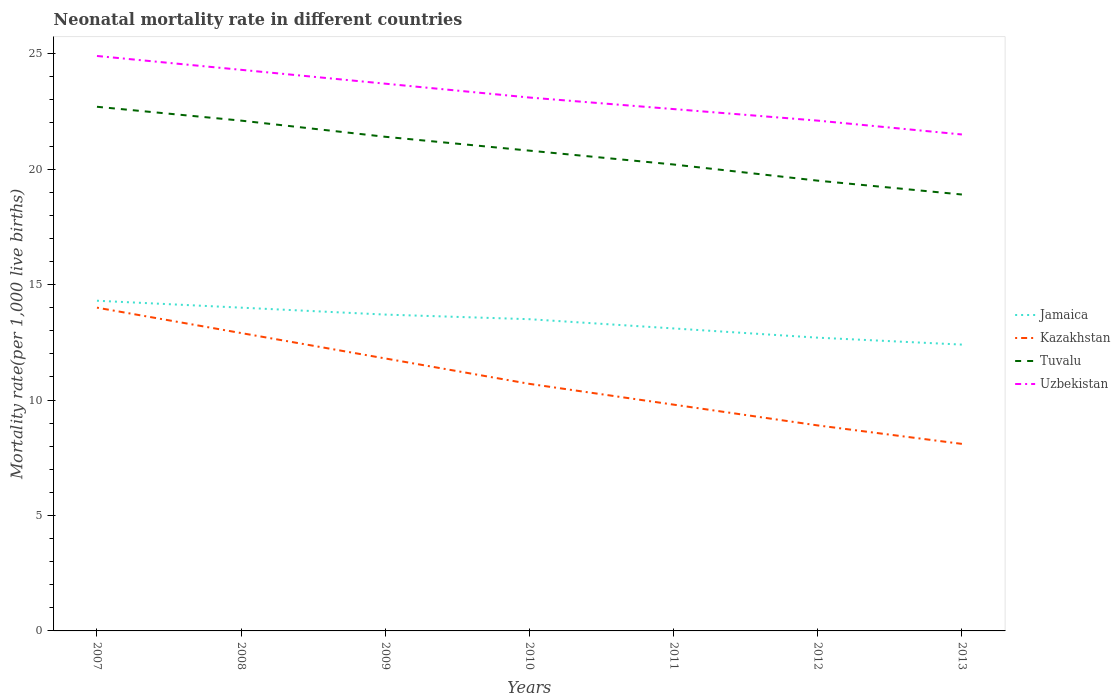Does the line corresponding to Jamaica intersect with the line corresponding to Kazakhstan?
Give a very brief answer. No. What is the total neonatal mortality rate in Tuvalu in the graph?
Provide a succinct answer. 1.9. What is the difference between the highest and the second highest neonatal mortality rate in Jamaica?
Ensure brevity in your answer.  1.9. Is the neonatal mortality rate in Jamaica strictly greater than the neonatal mortality rate in Tuvalu over the years?
Offer a terse response. Yes. How many lines are there?
Your answer should be compact. 4. How many years are there in the graph?
Keep it short and to the point. 7. Does the graph contain any zero values?
Your answer should be very brief. No. Does the graph contain grids?
Ensure brevity in your answer.  No. Where does the legend appear in the graph?
Your response must be concise. Center right. How are the legend labels stacked?
Your response must be concise. Vertical. What is the title of the graph?
Provide a short and direct response. Neonatal mortality rate in different countries. Does "Ukraine" appear as one of the legend labels in the graph?
Keep it short and to the point. No. What is the label or title of the Y-axis?
Your answer should be very brief. Mortality rate(per 1,0 live births). What is the Mortality rate(per 1,000 live births) in Jamaica in 2007?
Provide a succinct answer. 14.3. What is the Mortality rate(per 1,000 live births) of Kazakhstan in 2007?
Make the answer very short. 14. What is the Mortality rate(per 1,000 live births) of Tuvalu in 2007?
Make the answer very short. 22.7. What is the Mortality rate(per 1,000 live births) of Uzbekistan in 2007?
Your response must be concise. 24.9. What is the Mortality rate(per 1,000 live births) of Kazakhstan in 2008?
Keep it short and to the point. 12.9. What is the Mortality rate(per 1,000 live births) of Tuvalu in 2008?
Your answer should be compact. 22.1. What is the Mortality rate(per 1,000 live births) in Uzbekistan in 2008?
Provide a succinct answer. 24.3. What is the Mortality rate(per 1,000 live births) of Jamaica in 2009?
Provide a short and direct response. 13.7. What is the Mortality rate(per 1,000 live births) of Kazakhstan in 2009?
Give a very brief answer. 11.8. What is the Mortality rate(per 1,000 live births) of Tuvalu in 2009?
Offer a very short reply. 21.4. What is the Mortality rate(per 1,000 live births) of Uzbekistan in 2009?
Your answer should be compact. 23.7. What is the Mortality rate(per 1,000 live births) of Tuvalu in 2010?
Keep it short and to the point. 20.8. What is the Mortality rate(per 1,000 live births) of Uzbekistan in 2010?
Give a very brief answer. 23.1. What is the Mortality rate(per 1,000 live births) in Tuvalu in 2011?
Offer a terse response. 20.2. What is the Mortality rate(per 1,000 live births) in Uzbekistan in 2011?
Make the answer very short. 22.6. What is the Mortality rate(per 1,000 live births) of Jamaica in 2012?
Ensure brevity in your answer.  12.7. What is the Mortality rate(per 1,000 live births) in Tuvalu in 2012?
Your answer should be compact. 19.5. What is the Mortality rate(per 1,000 live births) in Uzbekistan in 2012?
Provide a short and direct response. 22.1. What is the Mortality rate(per 1,000 live births) of Jamaica in 2013?
Make the answer very short. 12.4. What is the Mortality rate(per 1,000 live births) in Kazakhstan in 2013?
Offer a very short reply. 8.1. What is the Mortality rate(per 1,000 live births) in Tuvalu in 2013?
Ensure brevity in your answer.  18.9. Across all years, what is the maximum Mortality rate(per 1,000 live births) in Tuvalu?
Give a very brief answer. 22.7. Across all years, what is the maximum Mortality rate(per 1,000 live births) in Uzbekistan?
Give a very brief answer. 24.9. Across all years, what is the minimum Mortality rate(per 1,000 live births) of Jamaica?
Make the answer very short. 12.4. Across all years, what is the minimum Mortality rate(per 1,000 live births) of Tuvalu?
Provide a short and direct response. 18.9. Across all years, what is the minimum Mortality rate(per 1,000 live births) in Uzbekistan?
Your answer should be compact. 21.5. What is the total Mortality rate(per 1,000 live births) of Jamaica in the graph?
Provide a short and direct response. 93.7. What is the total Mortality rate(per 1,000 live births) in Kazakhstan in the graph?
Make the answer very short. 76.2. What is the total Mortality rate(per 1,000 live births) of Tuvalu in the graph?
Keep it short and to the point. 145.6. What is the total Mortality rate(per 1,000 live births) in Uzbekistan in the graph?
Give a very brief answer. 162.2. What is the difference between the Mortality rate(per 1,000 live births) of Kazakhstan in 2007 and that in 2008?
Your answer should be compact. 1.1. What is the difference between the Mortality rate(per 1,000 live births) of Kazakhstan in 2007 and that in 2009?
Provide a succinct answer. 2.2. What is the difference between the Mortality rate(per 1,000 live births) of Tuvalu in 2007 and that in 2009?
Your answer should be compact. 1.3. What is the difference between the Mortality rate(per 1,000 live births) in Uzbekistan in 2007 and that in 2009?
Keep it short and to the point. 1.2. What is the difference between the Mortality rate(per 1,000 live births) of Uzbekistan in 2007 and that in 2010?
Provide a succinct answer. 1.8. What is the difference between the Mortality rate(per 1,000 live births) of Uzbekistan in 2007 and that in 2011?
Provide a succinct answer. 2.3. What is the difference between the Mortality rate(per 1,000 live births) in Tuvalu in 2007 and that in 2012?
Make the answer very short. 3.2. What is the difference between the Mortality rate(per 1,000 live births) of Jamaica in 2007 and that in 2013?
Ensure brevity in your answer.  1.9. What is the difference between the Mortality rate(per 1,000 live births) of Kazakhstan in 2007 and that in 2013?
Offer a terse response. 5.9. What is the difference between the Mortality rate(per 1,000 live births) in Tuvalu in 2007 and that in 2013?
Make the answer very short. 3.8. What is the difference between the Mortality rate(per 1,000 live births) in Uzbekistan in 2007 and that in 2013?
Keep it short and to the point. 3.4. What is the difference between the Mortality rate(per 1,000 live births) in Jamaica in 2008 and that in 2009?
Provide a succinct answer. 0.3. What is the difference between the Mortality rate(per 1,000 live births) in Uzbekistan in 2008 and that in 2009?
Your answer should be very brief. 0.6. What is the difference between the Mortality rate(per 1,000 live births) in Jamaica in 2008 and that in 2010?
Your response must be concise. 0.5. What is the difference between the Mortality rate(per 1,000 live births) in Tuvalu in 2008 and that in 2010?
Provide a short and direct response. 1.3. What is the difference between the Mortality rate(per 1,000 live births) in Jamaica in 2008 and that in 2011?
Your answer should be very brief. 0.9. What is the difference between the Mortality rate(per 1,000 live births) in Uzbekistan in 2008 and that in 2011?
Provide a succinct answer. 1.7. What is the difference between the Mortality rate(per 1,000 live births) of Jamaica in 2008 and that in 2013?
Ensure brevity in your answer.  1.6. What is the difference between the Mortality rate(per 1,000 live births) in Tuvalu in 2008 and that in 2013?
Your response must be concise. 3.2. What is the difference between the Mortality rate(per 1,000 live births) in Uzbekistan in 2008 and that in 2013?
Offer a very short reply. 2.8. What is the difference between the Mortality rate(per 1,000 live births) in Jamaica in 2009 and that in 2010?
Give a very brief answer. 0.2. What is the difference between the Mortality rate(per 1,000 live births) of Tuvalu in 2009 and that in 2010?
Keep it short and to the point. 0.6. What is the difference between the Mortality rate(per 1,000 live births) in Kazakhstan in 2009 and that in 2011?
Keep it short and to the point. 2. What is the difference between the Mortality rate(per 1,000 live births) of Tuvalu in 2009 and that in 2011?
Your answer should be compact. 1.2. What is the difference between the Mortality rate(per 1,000 live births) in Uzbekistan in 2009 and that in 2011?
Your answer should be very brief. 1.1. What is the difference between the Mortality rate(per 1,000 live births) of Kazakhstan in 2009 and that in 2012?
Give a very brief answer. 2.9. What is the difference between the Mortality rate(per 1,000 live births) of Uzbekistan in 2009 and that in 2012?
Keep it short and to the point. 1.6. What is the difference between the Mortality rate(per 1,000 live births) in Jamaica in 2010 and that in 2011?
Keep it short and to the point. 0.4. What is the difference between the Mortality rate(per 1,000 live births) in Tuvalu in 2010 and that in 2011?
Offer a very short reply. 0.6. What is the difference between the Mortality rate(per 1,000 live births) in Kazakhstan in 2010 and that in 2013?
Ensure brevity in your answer.  2.6. What is the difference between the Mortality rate(per 1,000 live births) in Uzbekistan in 2010 and that in 2013?
Your response must be concise. 1.6. What is the difference between the Mortality rate(per 1,000 live births) of Kazakhstan in 2011 and that in 2012?
Give a very brief answer. 0.9. What is the difference between the Mortality rate(per 1,000 live births) in Tuvalu in 2011 and that in 2012?
Your answer should be very brief. 0.7. What is the difference between the Mortality rate(per 1,000 live births) in Kazakhstan in 2011 and that in 2013?
Your response must be concise. 1.7. What is the difference between the Mortality rate(per 1,000 live births) of Tuvalu in 2011 and that in 2013?
Your answer should be compact. 1.3. What is the difference between the Mortality rate(per 1,000 live births) of Uzbekistan in 2011 and that in 2013?
Make the answer very short. 1.1. What is the difference between the Mortality rate(per 1,000 live births) in Jamaica in 2012 and that in 2013?
Provide a succinct answer. 0.3. What is the difference between the Mortality rate(per 1,000 live births) in Kazakhstan in 2012 and that in 2013?
Offer a terse response. 0.8. What is the difference between the Mortality rate(per 1,000 live births) in Tuvalu in 2012 and that in 2013?
Give a very brief answer. 0.6. What is the difference between the Mortality rate(per 1,000 live births) of Uzbekistan in 2012 and that in 2013?
Make the answer very short. 0.6. What is the difference between the Mortality rate(per 1,000 live births) in Jamaica in 2007 and the Mortality rate(per 1,000 live births) in Kazakhstan in 2008?
Offer a terse response. 1.4. What is the difference between the Mortality rate(per 1,000 live births) of Kazakhstan in 2007 and the Mortality rate(per 1,000 live births) of Tuvalu in 2008?
Your answer should be very brief. -8.1. What is the difference between the Mortality rate(per 1,000 live births) in Kazakhstan in 2007 and the Mortality rate(per 1,000 live births) in Uzbekistan in 2008?
Your answer should be very brief. -10.3. What is the difference between the Mortality rate(per 1,000 live births) in Tuvalu in 2007 and the Mortality rate(per 1,000 live births) in Uzbekistan in 2008?
Your answer should be compact. -1.6. What is the difference between the Mortality rate(per 1,000 live births) in Jamaica in 2007 and the Mortality rate(per 1,000 live births) in Tuvalu in 2009?
Make the answer very short. -7.1. What is the difference between the Mortality rate(per 1,000 live births) in Jamaica in 2007 and the Mortality rate(per 1,000 live births) in Uzbekistan in 2009?
Keep it short and to the point. -9.4. What is the difference between the Mortality rate(per 1,000 live births) in Kazakhstan in 2007 and the Mortality rate(per 1,000 live births) in Tuvalu in 2009?
Make the answer very short. -7.4. What is the difference between the Mortality rate(per 1,000 live births) of Tuvalu in 2007 and the Mortality rate(per 1,000 live births) of Uzbekistan in 2009?
Give a very brief answer. -1. What is the difference between the Mortality rate(per 1,000 live births) of Jamaica in 2007 and the Mortality rate(per 1,000 live births) of Kazakhstan in 2010?
Give a very brief answer. 3.6. What is the difference between the Mortality rate(per 1,000 live births) of Jamaica in 2007 and the Mortality rate(per 1,000 live births) of Tuvalu in 2010?
Your answer should be very brief. -6.5. What is the difference between the Mortality rate(per 1,000 live births) of Jamaica in 2007 and the Mortality rate(per 1,000 live births) of Uzbekistan in 2010?
Make the answer very short. -8.8. What is the difference between the Mortality rate(per 1,000 live births) of Jamaica in 2007 and the Mortality rate(per 1,000 live births) of Kazakhstan in 2011?
Make the answer very short. 4.5. What is the difference between the Mortality rate(per 1,000 live births) of Jamaica in 2007 and the Mortality rate(per 1,000 live births) of Kazakhstan in 2012?
Offer a terse response. 5.4. What is the difference between the Mortality rate(per 1,000 live births) of Jamaica in 2007 and the Mortality rate(per 1,000 live births) of Tuvalu in 2012?
Make the answer very short. -5.2. What is the difference between the Mortality rate(per 1,000 live births) in Jamaica in 2007 and the Mortality rate(per 1,000 live births) in Uzbekistan in 2012?
Your answer should be compact. -7.8. What is the difference between the Mortality rate(per 1,000 live births) of Jamaica in 2007 and the Mortality rate(per 1,000 live births) of Uzbekistan in 2013?
Offer a very short reply. -7.2. What is the difference between the Mortality rate(per 1,000 live births) in Tuvalu in 2007 and the Mortality rate(per 1,000 live births) in Uzbekistan in 2013?
Provide a short and direct response. 1.2. What is the difference between the Mortality rate(per 1,000 live births) of Jamaica in 2008 and the Mortality rate(per 1,000 live births) of Tuvalu in 2009?
Offer a very short reply. -7.4. What is the difference between the Mortality rate(per 1,000 live births) of Kazakhstan in 2008 and the Mortality rate(per 1,000 live births) of Tuvalu in 2009?
Offer a terse response. -8.5. What is the difference between the Mortality rate(per 1,000 live births) of Tuvalu in 2008 and the Mortality rate(per 1,000 live births) of Uzbekistan in 2009?
Ensure brevity in your answer.  -1.6. What is the difference between the Mortality rate(per 1,000 live births) in Jamaica in 2008 and the Mortality rate(per 1,000 live births) in Kazakhstan in 2010?
Give a very brief answer. 3.3. What is the difference between the Mortality rate(per 1,000 live births) in Jamaica in 2008 and the Mortality rate(per 1,000 live births) in Tuvalu in 2010?
Offer a terse response. -6.8. What is the difference between the Mortality rate(per 1,000 live births) of Jamaica in 2008 and the Mortality rate(per 1,000 live births) of Uzbekistan in 2010?
Provide a succinct answer. -9.1. What is the difference between the Mortality rate(per 1,000 live births) in Tuvalu in 2008 and the Mortality rate(per 1,000 live births) in Uzbekistan in 2010?
Offer a terse response. -1. What is the difference between the Mortality rate(per 1,000 live births) of Jamaica in 2008 and the Mortality rate(per 1,000 live births) of Kazakhstan in 2011?
Offer a very short reply. 4.2. What is the difference between the Mortality rate(per 1,000 live births) in Jamaica in 2008 and the Mortality rate(per 1,000 live births) in Uzbekistan in 2011?
Your answer should be compact. -8.6. What is the difference between the Mortality rate(per 1,000 live births) in Kazakhstan in 2008 and the Mortality rate(per 1,000 live births) in Tuvalu in 2011?
Give a very brief answer. -7.3. What is the difference between the Mortality rate(per 1,000 live births) of Jamaica in 2008 and the Mortality rate(per 1,000 live births) of Kazakhstan in 2012?
Keep it short and to the point. 5.1. What is the difference between the Mortality rate(per 1,000 live births) in Jamaica in 2008 and the Mortality rate(per 1,000 live births) in Tuvalu in 2012?
Your answer should be very brief. -5.5. What is the difference between the Mortality rate(per 1,000 live births) of Jamaica in 2008 and the Mortality rate(per 1,000 live births) of Uzbekistan in 2012?
Make the answer very short. -8.1. What is the difference between the Mortality rate(per 1,000 live births) in Kazakhstan in 2008 and the Mortality rate(per 1,000 live births) in Uzbekistan in 2012?
Keep it short and to the point. -9.2. What is the difference between the Mortality rate(per 1,000 live births) in Jamaica in 2008 and the Mortality rate(per 1,000 live births) in Kazakhstan in 2013?
Make the answer very short. 5.9. What is the difference between the Mortality rate(per 1,000 live births) of Jamaica in 2008 and the Mortality rate(per 1,000 live births) of Tuvalu in 2013?
Provide a short and direct response. -4.9. What is the difference between the Mortality rate(per 1,000 live births) in Jamaica in 2008 and the Mortality rate(per 1,000 live births) in Uzbekistan in 2013?
Ensure brevity in your answer.  -7.5. What is the difference between the Mortality rate(per 1,000 live births) in Kazakhstan in 2008 and the Mortality rate(per 1,000 live births) in Tuvalu in 2013?
Make the answer very short. -6. What is the difference between the Mortality rate(per 1,000 live births) in Kazakhstan in 2008 and the Mortality rate(per 1,000 live births) in Uzbekistan in 2013?
Offer a very short reply. -8.6. What is the difference between the Mortality rate(per 1,000 live births) of Tuvalu in 2008 and the Mortality rate(per 1,000 live births) of Uzbekistan in 2013?
Keep it short and to the point. 0.6. What is the difference between the Mortality rate(per 1,000 live births) in Jamaica in 2009 and the Mortality rate(per 1,000 live births) in Uzbekistan in 2010?
Provide a short and direct response. -9.4. What is the difference between the Mortality rate(per 1,000 live births) in Kazakhstan in 2009 and the Mortality rate(per 1,000 live births) in Tuvalu in 2010?
Keep it short and to the point. -9. What is the difference between the Mortality rate(per 1,000 live births) of Kazakhstan in 2009 and the Mortality rate(per 1,000 live births) of Uzbekistan in 2010?
Offer a very short reply. -11.3. What is the difference between the Mortality rate(per 1,000 live births) in Tuvalu in 2009 and the Mortality rate(per 1,000 live births) in Uzbekistan in 2010?
Provide a succinct answer. -1.7. What is the difference between the Mortality rate(per 1,000 live births) of Jamaica in 2009 and the Mortality rate(per 1,000 live births) of Tuvalu in 2011?
Your answer should be compact. -6.5. What is the difference between the Mortality rate(per 1,000 live births) of Jamaica in 2009 and the Mortality rate(per 1,000 live births) of Uzbekistan in 2011?
Provide a succinct answer. -8.9. What is the difference between the Mortality rate(per 1,000 live births) in Kazakhstan in 2009 and the Mortality rate(per 1,000 live births) in Tuvalu in 2011?
Keep it short and to the point. -8.4. What is the difference between the Mortality rate(per 1,000 live births) of Tuvalu in 2009 and the Mortality rate(per 1,000 live births) of Uzbekistan in 2011?
Keep it short and to the point. -1.2. What is the difference between the Mortality rate(per 1,000 live births) in Jamaica in 2009 and the Mortality rate(per 1,000 live births) in Uzbekistan in 2012?
Offer a very short reply. -8.4. What is the difference between the Mortality rate(per 1,000 live births) in Kazakhstan in 2009 and the Mortality rate(per 1,000 live births) in Uzbekistan in 2012?
Give a very brief answer. -10.3. What is the difference between the Mortality rate(per 1,000 live births) of Jamaica in 2009 and the Mortality rate(per 1,000 live births) of Tuvalu in 2013?
Offer a terse response. -5.2. What is the difference between the Mortality rate(per 1,000 live births) in Kazakhstan in 2009 and the Mortality rate(per 1,000 live births) in Uzbekistan in 2013?
Your response must be concise. -9.7. What is the difference between the Mortality rate(per 1,000 live births) in Tuvalu in 2009 and the Mortality rate(per 1,000 live births) in Uzbekistan in 2013?
Your answer should be compact. -0.1. What is the difference between the Mortality rate(per 1,000 live births) in Jamaica in 2010 and the Mortality rate(per 1,000 live births) in Kazakhstan in 2011?
Your answer should be compact. 3.7. What is the difference between the Mortality rate(per 1,000 live births) of Jamaica in 2010 and the Mortality rate(per 1,000 live births) of Tuvalu in 2011?
Keep it short and to the point. -6.7. What is the difference between the Mortality rate(per 1,000 live births) in Jamaica in 2010 and the Mortality rate(per 1,000 live births) in Uzbekistan in 2011?
Offer a very short reply. -9.1. What is the difference between the Mortality rate(per 1,000 live births) of Tuvalu in 2010 and the Mortality rate(per 1,000 live births) of Uzbekistan in 2011?
Keep it short and to the point. -1.8. What is the difference between the Mortality rate(per 1,000 live births) of Jamaica in 2010 and the Mortality rate(per 1,000 live births) of Kazakhstan in 2012?
Offer a terse response. 4.6. What is the difference between the Mortality rate(per 1,000 live births) in Jamaica in 2010 and the Mortality rate(per 1,000 live births) in Tuvalu in 2012?
Offer a terse response. -6. What is the difference between the Mortality rate(per 1,000 live births) in Jamaica in 2010 and the Mortality rate(per 1,000 live births) in Uzbekistan in 2012?
Give a very brief answer. -8.6. What is the difference between the Mortality rate(per 1,000 live births) in Kazakhstan in 2010 and the Mortality rate(per 1,000 live births) in Uzbekistan in 2012?
Offer a very short reply. -11.4. What is the difference between the Mortality rate(per 1,000 live births) in Tuvalu in 2010 and the Mortality rate(per 1,000 live births) in Uzbekistan in 2012?
Your answer should be compact. -1.3. What is the difference between the Mortality rate(per 1,000 live births) in Jamaica in 2010 and the Mortality rate(per 1,000 live births) in Uzbekistan in 2013?
Make the answer very short. -8. What is the difference between the Mortality rate(per 1,000 live births) in Kazakhstan in 2010 and the Mortality rate(per 1,000 live births) in Uzbekistan in 2013?
Offer a very short reply. -10.8. What is the difference between the Mortality rate(per 1,000 live births) of Jamaica in 2011 and the Mortality rate(per 1,000 live births) of Tuvalu in 2012?
Your answer should be very brief. -6.4. What is the difference between the Mortality rate(per 1,000 live births) in Jamaica in 2011 and the Mortality rate(per 1,000 live births) in Uzbekistan in 2012?
Make the answer very short. -9. What is the difference between the Mortality rate(per 1,000 live births) of Kazakhstan in 2011 and the Mortality rate(per 1,000 live births) of Uzbekistan in 2012?
Make the answer very short. -12.3. What is the difference between the Mortality rate(per 1,000 live births) in Jamaica in 2011 and the Mortality rate(per 1,000 live births) in Kazakhstan in 2013?
Offer a very short reply. 5. What is the difference between the Mortality rate(per 1,000 live births) in Jamaica in 2011 and the Mortality rate(per 1,000 live births) in Uzbekistan in 2013?
Offer a very short reply. -8.4. What is the difference between the Mortality rate(per 1,000 live births) in Kazakhstan in 2011 and the Mortality rate(per 1,000 live births) in Tuvalu in 2013?
Your response must be concise. -9.1. What is the difference between the Mortality rate(per 1,000 live births) of Jamaica in 2012 and the Mortality rate(per 1,000 live births) of Kazakhstan in 2013?
Keep it short and to the point. 4.6. What is the difference between the Mortality rate(per 1,000 live births) in Jamaica in 2012 and the Mortality rate(per 1,000 live births) in Uzbekistan in 2013?
Your response must be concise. -8.8. What is the difference between the Mortality rate(per 1,000 live births) of Tuvalu in 2012 and the Mortality rate(per 1,000 live births) of Uzbekistan in 2013?
Provide a short and direct response. -2. What is the average Mortality rate(per 1,000 live births) of Jamaica per year?
Offer a terse response. 13.39. What is the average Mortality rate(per 1,000 live births) of Kazakhstan per year?
Make the answer very short. 10.89. What is the average Mortality rate(per 1,000 live births) in Tuvalu per year?
Provide a succinct answer. 20.8. What is the average Mortality rate(per 1,000 live births) in Uzbekistan per year?
Your answer should be compact. 23.17. In the year 2007, what is the difference between the Mortality rate(per 1,000 live births) of Jamaica and Mortality rate(per 1,000 live births) of Tuvalu?
Give a very brief answer. -8.4. In the year 2007, what is the difference between the Mortality rate(per 1,000 live births) of Kazakhstan and Mortality rate(per 1,000 live births) of Uzbekistan?
Offer a very short reply. -10.9. In the year 2008, what is the difference between the Mortality rate(per 1,000 live births) of Jamaica and Mortality rate(per 1,000 live births) of Kazakhstan?
Your answer should be very brief. 1.1. In the year 2008, what is the difference between the Mortality rate(per 1,000 live births) of Jamaica and Mortality rate(per 1,000 live births) of Tuvalu?
Keep it short and to the point. -8.1. In the year 2008, what is the difference between the Mortality rate(per 1,000 live births) of Kazakhstan and Mortality rate(per 1,000 live births) of Uzbekistan?
Your answer should be very brief. -11.4. In the year 2008, what is the difference between the Mortality rate(per 1,000 live births) of Tuvalu and Mortality rate(per 1,000 live births) of Uzbekistan?
Provide a short and direct response. -2.2. In the year 2009, what is the difference between the Mortality rate(per 1,000 live births) of Jamaica and Mortality rate(per 1,000 live births) of Kazakhstan?
Offer a very short reply. 1.9. In the year 2009, what is the difference between the Mortality rate(per 1,000 live births) of Jamaica and Mortality rate(per 1,000 live births) of Uzbekistan?
Make the answer very short. -10. In the year 2009, what is the difference between the Mortality rate(per 1,000 live births) of Kazakhstan and Mortality rate(per 1,000 live births) of Tuvalu?
Your answer should be compact. -9.6. In the year 2010, what is the difference between the Mortality rate(per 1,000 live births) in Kazakhstan and Mortality rate(per 1,000 live births) in Tuvalu?
Your answer should be compact. -10.1. In the year 2011, what is the difference between the Mortality rate(per 1,000 live births) of Jamaica and Mortality rate(per 1,000 live births) of Uzbekistan?
Make the answer very short. -9.5. In the year 2011, what is the difference between the Mortality rate(per 1,000 live births) in Kazakhstan and Mortality rate(per 1,000 live births) in Tuvalu?
Give a very brief answer. -10.4. In the year 2011, what is the difference between the Mortality rate(per 1,000 live births) of Kazakhstan and Mortality rate(per 1,000 live births) of Uzbekistan?
Your response must be concise. -12.8. In the year 2012, what is the difference between the Mortality rate(per 1,000 live births) in Tuvalu and Mortality rate(per 1,000 live births) in Uzbekistan?
Your response must be concise. -2.6. In the year 2013, what is the difference between the Mortality rate(per 1,000 live births) in Jamaica and Mortality rate(per 1,000 live births) in Tuvalu?
Provide a succinct answer. -6.5. In the year 2013, what is the difference between the Mortality rate(per 1,000 live births) of Jamaica and Mortality rate(per 1,000 live births) of Uzbekistan?
Your answer should be compact. -9.1. What is the ratio of the Mortality rate(per 1,000 live births) of Jamaica in 2007 to that in 2008?
Ensure brevity in your answer.  1.02. What is the ratio of the Mortality rate(per 1,000 live births) of Kazakhstan in 2007 to that in 2008?
Keep it short and to the point. 1.09. What is the ratio of the Mortality rate(per 1,000 live births) in Tuvalu in 2007 to that in 2008?
Your answer should be very brief. 1.03. What is the ratio of the Mortality rate(per 1,000 live births) of Uzbekistan in 2007 to that in 2008?
Make the answer very short. 1.02. What is the ratio of the Mortality rate(per 1,000 live births) of Jamaica in 2007 to that in 2009?
Give a very brief answer. 1.04. What is the ratio of the Mortality rate(per 1,000 live births) of Kazakhstan in 2007 to that in 2009?
Make the answer very short. 1.19. What is the ratio of the Mortality rate(per 1,000 live births) in Tuvalu in 2007 to that in 2009?
Your answer should be very brief. 1.06. What is the ratio of the Mortality rate(per 1,000 live births) of Uzbekistan in 2007 to that in 2009?
Make the answer very short. 1.05. What is the ratio of the Mortality rate(per 1,000 live births) of Jamaica in 2007 to that in 2010?
Provide a succinct answer. 1.06. What is the ratio of the Mortality rate(per 1,000 live births) in Kazakhstan in 2007 to that in 2010?
Offer a very short reply. 1.31. What is the ratio of the Mortality rate(per 1,000 live births) in Tuvalu in 2007 to that in 2010?
Provide a succinct answer. 1.09. What is the ratio of the Mortality rate(per 1,000 live births) of Uzbekistan in 2007 to that in 2010?
Make the answer very short. 1.08. What is the ratio of the Mortality rate(per 1,000 live births) in Jamaica in 2007 to that in 2011?
Keep it short and to the point. 1.09. What is the ratio of the Mortality rate(per 1,000 live births) of Kazakhstan in 2007 to that in 2011?
Your answer should be compact. 1.43. What is the ratio of the Mortality rate(per 1,000 live births) of Tuvalu in 2007 to that in 2011?
Give a very brief answer. 1.12. What is the ratio of the Mortality rate(per 1,000 live births) of Uzbekistan in 2007 to that in 2011?
Make the answer very short. 1.1. What is the ratio of the Mortality rate(per 1,000 live births) of Jamaica in 2007 to that in 2012?
Your answer should be very brief. 1.13. What is the ratio of the Mortality rate(per 1,000 live births) in Kazakhstan in 2007 to that in 2012?
Offer a very short reply. 1.57. What is the ratio of the Mortality rate(per 1,000 live births) of Tuvalu in 2007 to that in 2012?
Provide a succinct answer. 1.16. What is the ratio of the Mortality rate(per 1,000 live births) in Uzbekistan in 2007 to that in 2012?
Give a very brief answer. 1.13. What is the ratio of the Mortality rate(per 1,000 live births) of Jamaica in 2007 to that in 2013?
Your answer should be compact. 1.15. What is the ratio of the Mortality rate(per 1,000 live births) in Kazakhstan in 2007 to that in 2013?
Make the answer very short. 1.73. What is the ratio of the Mortality rate(per 1,000 live births) of Tuvalu in 2007 to that in 2013?
Provide a short and direct response. 1.2. What is the ratio of the Mortality rate(per 1,000 live births) in Uzbekistan in 2007 to that in 2013?
Offer a very short reply. 1.16. What is the ratio of the Mortality rate(per 1,000 live births) in Jamaica in 2008 to that in 2009?
Ensure brevity in your answer.  1.02. What is the ratio of the Mortality rate(per 1,000 live births) in Kazakhstan in 2008 to that in 2009?
Your answer should be compact. 1.09. What is the ratio of the Mortality rate(per 1,000 live births) in Tuvalu in 2008 to that in 2009?
Provide a short and direct response. 1.03. What is the ratio of the Mortality rate(per 1,000 live births) of Uzbekistan in 2008 to that in 2009?
Your answer should be compact. 1.03. What is the ratio of the Mortality rate(per 1,000 live births) of Kazakhstan in 2008 to that in 2010?
Offer a terse response. 1.21. What is the ratio of the Mortality rate(per 1,000 live births) in Uzbekistan in 2008 to that in 2010?
Your response must be concise. 1.05. What is the ratio of the Mortality rate(per 1,000 live births) of Jamaica in 2008 to that in 2011?
Provide a succinct answer. 1.07. What is the ratio of the Mortality rate(per 1,000 live births) in Kazakhstan in 2008 to that in 2011?
Your answer should be very brief. 1.32. What is the ratio of the Mortality rate(per 1,000 live births) in Tuvalu in 2008 to that in 2011?
Your response must be concise. 1.09. What is the ratio of the Mortality rate(per 1,000 live births) in Uzbekistan in 2008 to that in 2011?
Provide a short and direct response. 1.08. What is the ratio of the Mortality rate(per 1,000 live births) of Jamaica in 2008 to that in 2012?
Your response must be concise. 1.1. What is the ratio of the Mortality rate(per 1,000 live births) of Kazakhstan in 2008 to that in 2012?
Offer a terse response. 1.45. What is the ratio of the Mortality rate(per 1,000 live births) in Tuvalu in 2008 to that in 2012?
Give a very brief answer. 1.13. What is the ratio of the Mortality rate(per 1,000 live births) in Uzbekistan in 2008 to that in 2012?
Keep it short and to the point. 1.1. What is the ratio of the Mortality rate(per 1,000 live births) in Jamaica in 2008 to that in 2013?
Offer a very short reply. 1.13. What is the ratio of the Mortality rate(per 1,000 live births) of Kazakhstan in 2008 to that in 2013?
Ensure brevity in your answer.  1.59. What is the ratio of the Mortality rate(per 1,000 live births) of Tuvalu in 2008 to that in 2013?
Offer a very short reply. 1.17. What is the ratio of the Mortality rate(per 1,000 live births) in Uzbekistan in 2008 to that in 2013?
Your response must be concise. 1.13. What is the ratio of the Mortality rate(per 1,000 live births) of Jamaica in 2009 to that in 2010?
Keep it short and to the point. 1.01. What is the ratio of the Mortality rate(per 1,000 live births) of Kazakhstan in 2009 to that in 2010?
Make the answer very short. 1.1. What is the ratio of the Mortality rate(per 1,000 live births) in Tuvalu in 2009 to that in 2010?
Make the answer very short. 1.03. What is the ratio of the Mortality rate(per 1,000 live births) in Jamaica in 2009 to that in 2011?
Ensure brevity in your answer.  1.05. What is the ratio of the Mortality rate(per 1,000 live births) of Kazakhstan in 2009 to that in 2011?
Offer a very short reply. 1.2. What is the ratio of the Mortality rate(per 1,000 live births) of Tuvalu in 2009 to that in 2011?
Offer a terse response. 1.06. What is the ratio of the Mortality rate(per 1,000 live births) of Uzbekistan in 2009 to that in 2011?
Make the answer very short. 1.05. What is the ratio of the Mortality rate(per 1,000 live births) of Jamaica in 2009 to that in 2012?
Your response must be concise. 1.08. What is the ratio of the Mortality rate(per 1,000 live births) in Kazakhstan in 2009 to that in 2012?
Give a very brief answer. 1.33. What is the ratio of the Mortality rate(per 1,000 live births) in Tuvalu in 2009 to that in 2012?
Offer a very short reply. 1.1. What is the ratio of the Mortality rate(per 1,000 live births) in Uzbekistan in 2009 to that in 2012?
Ensure brevity in your answer.  1.07. What is the ratio of the Mortality rate(per 1,000 live births) of Jamaica in 2009 to that in 2013?
Provide a short and direct response. 1.1. What is the ratio of the Mortality rate(per 1,000 live births) of Kazakhstan in 2009 to that in 2013?
Keep it short and to the point. 1.46. What is the ratio of the Mortality rate(per 1,000 live births) in Tuvalu in 2009 to that in 2013?
Your response must be concise. 1.13. What is the ratio of the Mortality rate(per 1,000 live births) of Uzbekistan in 2009 to that in 2013?
Offer a very short reply. 1.1. What is the ratio of the Mortality rate(per 1,000 live births) of Jamaica in 2010 to that in 2011?
Your answer should be very brief. 1.03. What is the ratio of the Mortality rate(per 1,000 live births) in Kazakhstan in 2010 to that in 2011?
Your response must be concise. 1.09. What is the ratio of the Mortality rate(per 1,000 live births) of Tuvalu in 2010 to that in 2011?
Offer a terse response. 1.03. What is the ratio of the Mortality rate(per 1,000 live births) in Uzbekistan in 2010 to that in 2011?
Provide a short and direct response. 1.02. What is the ratio of the Mortality rate(per 1,000 live births) in Jamaica in 2010 to that in 2012?
Provide a succinct answer. 1.06. What is the ratio of the Mortality rate(per 1,000 live births) of Kazakhstan in 2010 to that in 2012?
Your response must be concise. 1.2. What is the ratio of the Mortality rate(per 1,000 live births) in Tuvalu in 2010 to that in 2012?
Give a very brief answer. 1.07. What is the ratio of the Mortality rate(per 1,000 live births) of Uzbekistan in 2010 to that in 2012?
Your answer should be very brief. 1.05. What is the ratio of the Mortality rate(per 1,000 live births) of Jamaica in 2010 to that in 2013?
Your response must be concise. 1.09. What is the ratio of the Mortality rate(per 1,000 live births) in Kazakhstan in 2010 to that in 2013?
Your answer should be compact. 1.32. What is the ratio of the Mortality rate(per 1,000 live births) of Tuvalu in 2010 to that in 2013?
Make the answer very short. 1.1. What is the ratio of the Mortality rate(per 1,000 live births) in Uzbekistan in 2010 to that in 2013?
Give a very brief answer. 1.07. What is the ratio of the Mortality rate(per 1,000 live births) of Jamaica in 2011 to that in 2012?
Keep it short and to the point. 1.03. What is the ratio of the Mortality rate(per 1,000 live births) of Kazakhstan in 2011 to that in 2012?
Your answer should be very brief. 1.1. What is the ratio of the Mortality rate(per 1,000 live births) in Tuvalu in 2011 to that in 2012?
Your answer should be very brief. 1.04. What is the ratio of the Mortality rate(per 1,000 live births) in Uzbekistan in 2011 to that in 2012?
Offer a terse response. 1.02. What is the ratio of the Mortality rate(per 1,000 live births) in Jamaica in 2011 to that in 2013?
Keep it short and to the point. 1.06. What is the ratio of the Mortality rate(per 1,000 live births) of Kazakhstan in 2011 to that in 2013?
Make the answer very short. 1.21. What is the ratio of the Mortality rate(per 1,000 live births) of Tuvalu in 2011 to that in 2013?
Your answer should be compact. 1.07. What is the ratio of the Mortality rate(per 1,000 live births) of Uzbekistan in 2011 to that in 2013?
Your answer should be compact. 1.05. What is the ratio of the Mortality rate(per 1,000 live births) of Jamaica in 2012 to that in 2013?
Give a very brief answer. 1.02. What is the ratio of the Mortality rate(per 1,000 live births) of Kazakhstan in 2012 to that in 2013?
Your answer should be very brief. 1.1. What is the ratio of the Mortality rate(per 1,000 live births) of Tuvalu in 2012 to that in 2013?
Your response must be concise. 1.03. What is the ratio of the Mortality rate(per 1,000 live births) in Uzbekistan in 2012 to that in 2013?
Provide a short and direct response. 1.03. What is the difference between the highest and the second highest Mortality rate(per 1,000 live births) of Kazakhstan?
Provide a short and direct response. 1.1. What is the difference between the highest and the lowest Mortality rate(per 1,000 live births) in Jamaica?
Your answer should be very brief. 1.9. What is the difference between the highest and the lowest Mortality rate(per 1,000 live births) in Kazakhstan?
Your answer should be compact. 5.9. What is the difference between the highest and the lowest Mortality rate(per 1,000 live births) of Tuvalu?
Offer a very short reply. 3.8. 